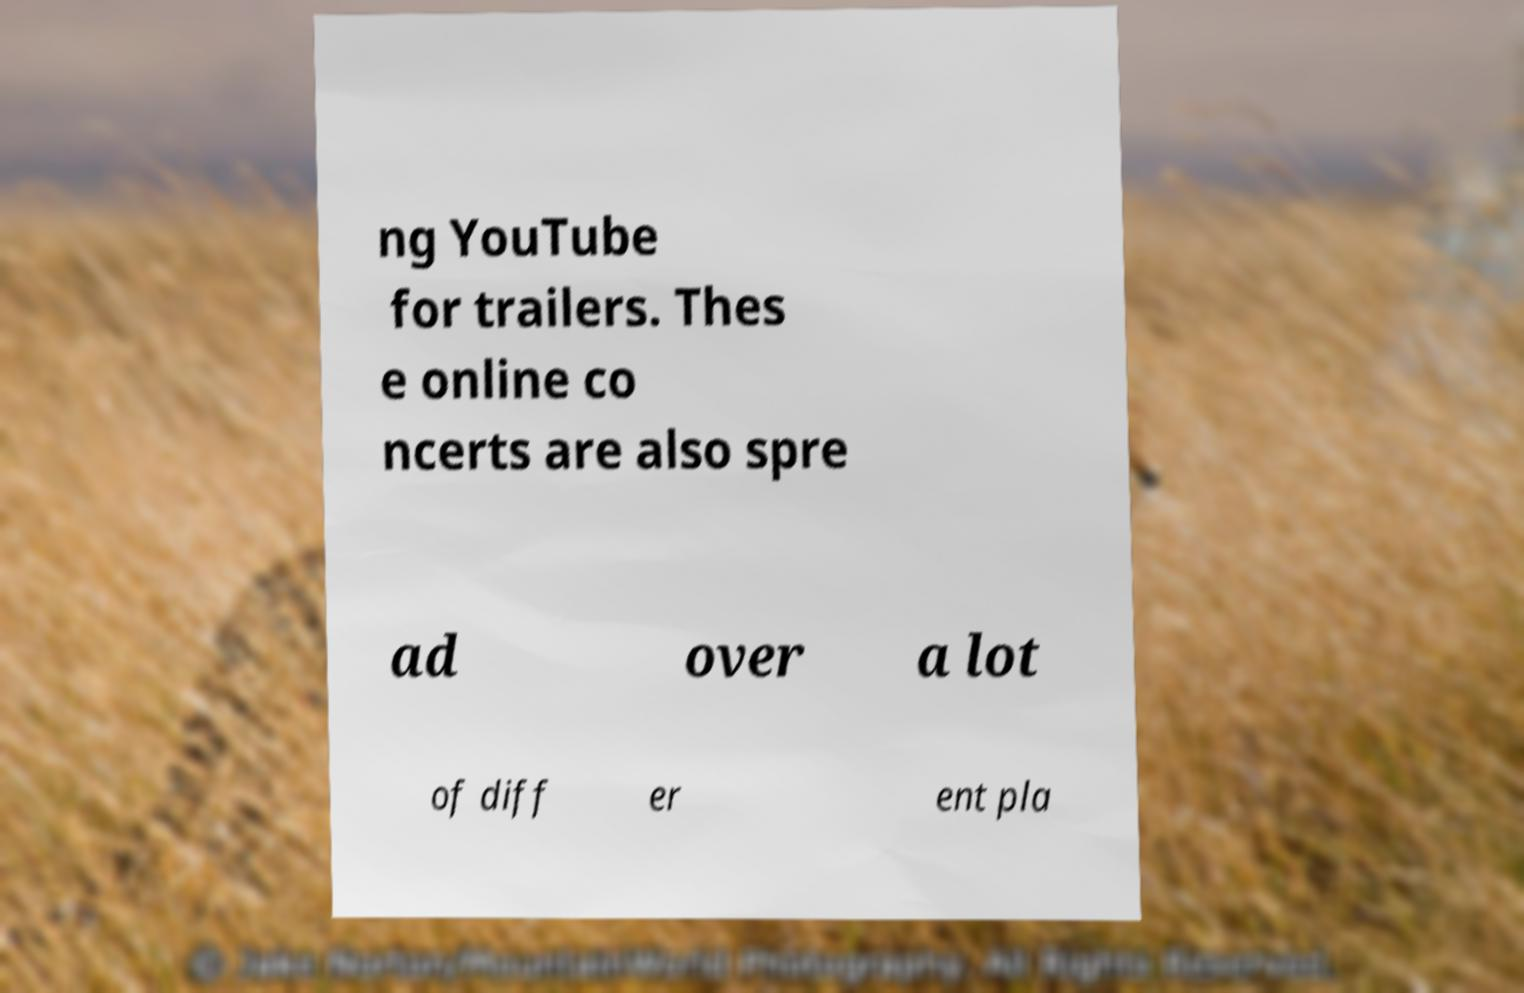Can you accurately transcribe the text from the provided image for me? ng YouTube for trailers. Thes e online co ncerts are also spre ad over a lot of diff er ent pla 